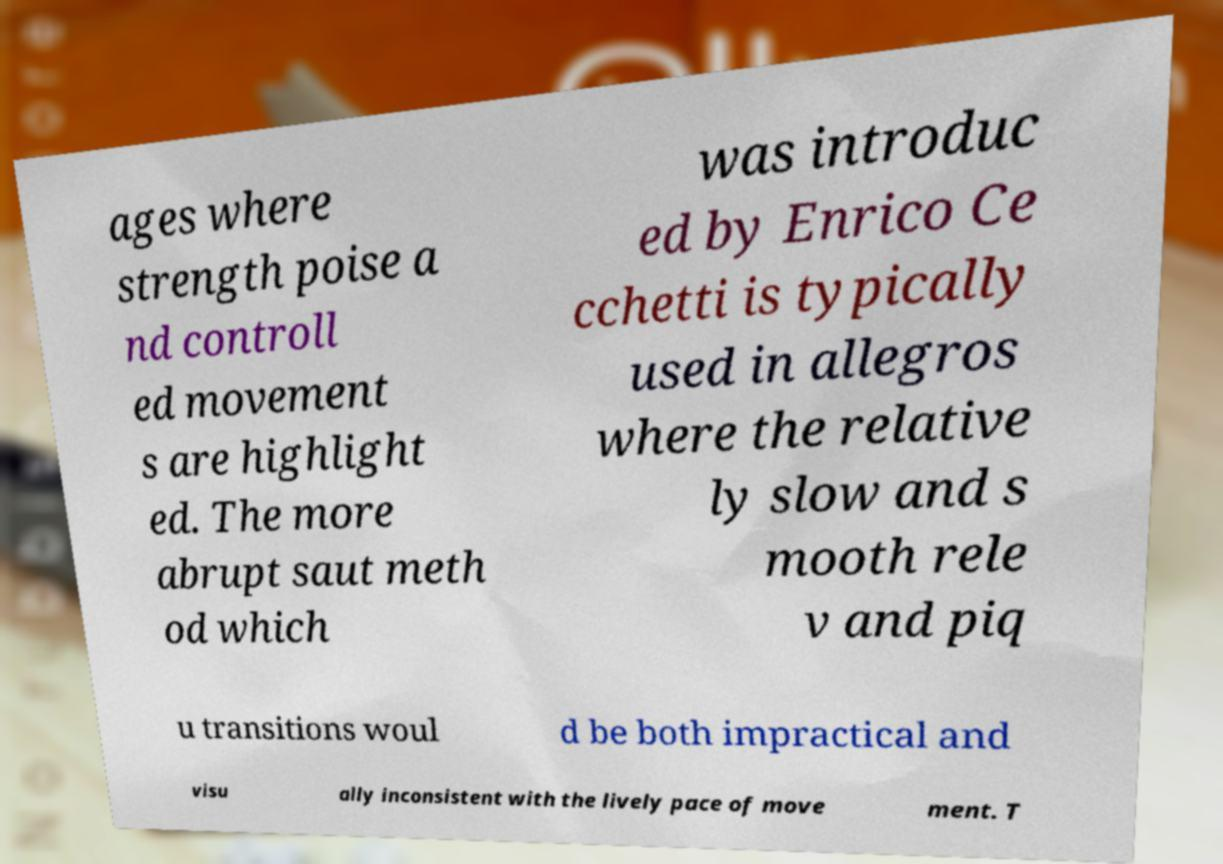What messages or text are displayed in this image? I need them in a readable, typed format. ages where strength poise a nd controll ed movement s are highlight ed. The more abrupt saut meth od which was introduc ed by Enrico Ce cchetti is typically used in allegros where the relative ly slow and s mooth rele v and piq u transitions woul d be both impractical and visu ally inconsistent with the lively pace of move ment. T 